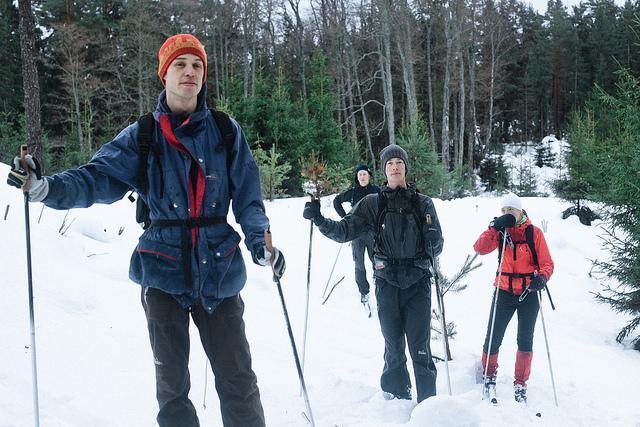How many people are wearing hats?
Give a very brief answer. 4. How many people are in the photo?
Give a very brief answer. 3. How many bicycles can you see in this photo?
Give a very brief answer. 0. 